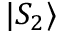Convert formula to latex. <formula><loc_0><loc_0><loc_500><loc_500>| S _ { 2 } \rangle</formula> 